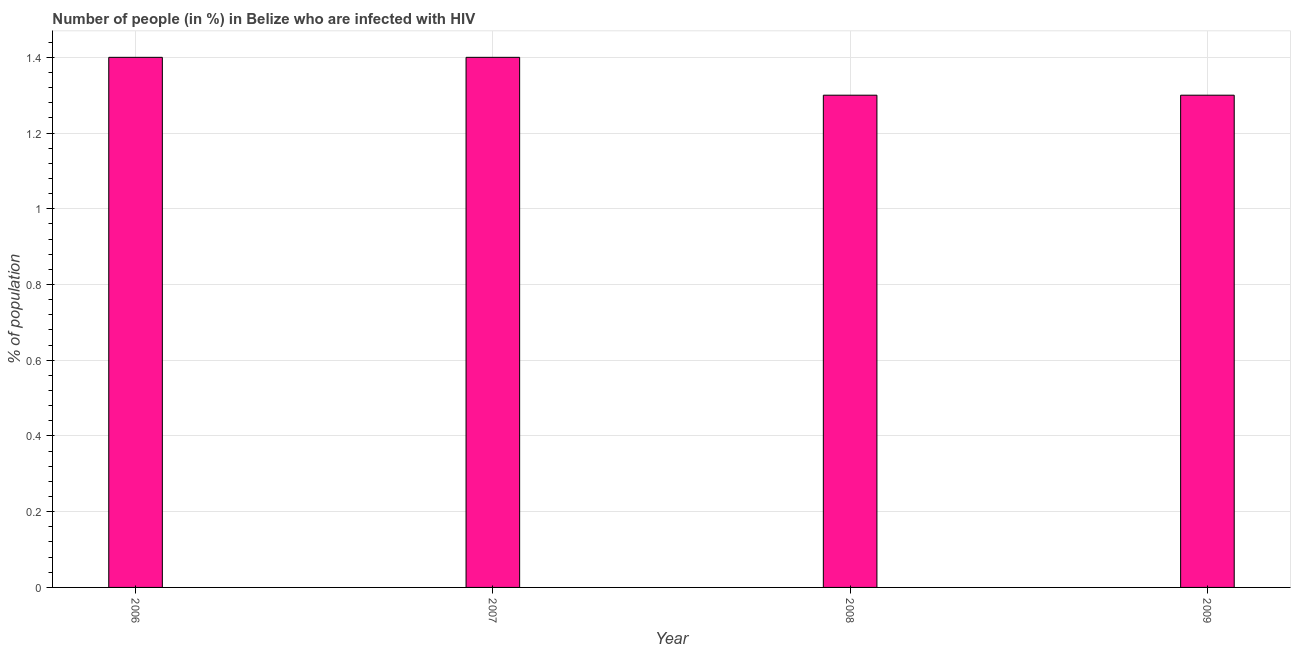What is the title of the graph?
Offer a very short reply. Number of people (in %) in Belize who are infected with HIV. What is the label or title of the Y-axis?
Your response must be concise. % of population. What is the number of people infected with hiv in 2006?
Provide a short and direct response. 1.4. Across all years, what is the maximum number of people infected with hiv?
Give a very brief answer. 1.4. In which year was the number of people infected with hiv maximum?
Offer a very short reply. 2006. In which year was the number of people infected with hiv minimum?
Your response must be concise. 2008. What is the sum of the number of people infected with hiv?
Ensure brevity in your answer.  5.4. What is the difference between the number of people infected with hiv in 2006 and 2007?
Your answer should be very brief. 0. What is the average number of people infected with hiv per year?
Offer a terse response. 1.35. What is the median number of people infected with hiv?
Provide a succinct answer. 1.35. In how many years, is the number of people infected with hiv greater than 1.08 %?
Your answer should be very brief. 4. What is the ratio of the number of people infected with hiv in 2007 to that in 2008?
Your answer should be very brief. 1.08. Is the number of people infected with hiv in 2006 less than that in 2007?
Keep it short and to the point. No. Is the difference between the number of people infected with hiv in 2006 and 2008 greater than the difference between any two years?
Offer a terse response. Yes. Is the sum of the number of people infected with hiv in 2007 and 2008 greater than the maximum number of people infected with hiv across all years?
Offer a very short reply. Yes. How many bars are there?
Ensure brevity in your answer.  4. Are all the bars in the graph horizontal?
Offer a very short reply. No. What is the difference between two consecutive major ticks on the Y-axis?
Your response must be concise. 0.2. What is the % of population in 2006?
Make the answer very short. 1.4. What is the % of population in 2009?
Provide a succinct answer. 1.3. What is the difference between the % of population in 2007 and 2008?
Make the answer very short. 0.1. What is the difference between the % of population in 2007 and 2009?
Ensure brevity in your answer.  0.1. What is the ratio of the % of population in 2006 to that in 2007?
Your answer should be very brief. 1. What is the ratio of the % of population in 2006 to that in 2008?
Make the answer very short. 1.08. What is the ratio of the % of population in 2006 to that in 2009?
Offer a terse response. 1.08. What is the ratio of the % of population in 2007 to that in 2008?
Provide a succinct answer. 1.08. What is the ratio of the % of population in 2007 to that in 2009?
Provide a succinct answer. 1.08. What is the ratio of the % of population in 2008 to that in 2009?
Ensure brevity in your answer.  1. 